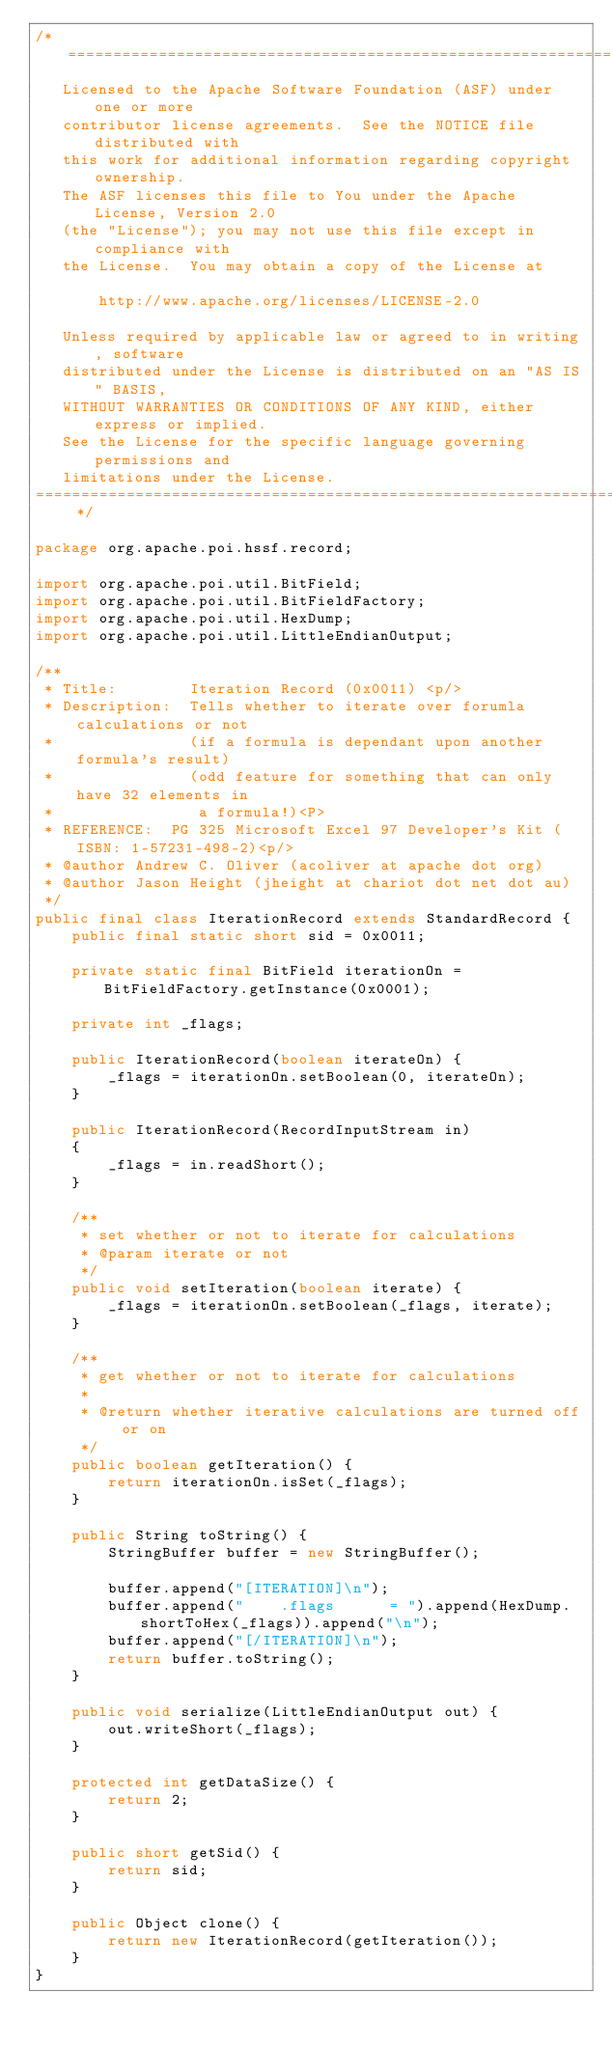Convert code to text. <code><loc_0><loc_0><loc_500><loc_500><_Java_>/* ====================================================================
   Licensed to the Apache Software Foundation (ASF) under one or more
   contributor license agreements.  See the NOTICE file distributed with
   this work for additional information regarding copyright ownership.
   The ASF licenses this file to You under the Apache License, Version 2.0
   (the "License"); you may not use this file except in compliance with
   the License.  You may obtain a copy of the License at

       http://www.apache.org/licenses/LICENSE-2.0

   Unless required by applicable law or agreed to in writing, software
   distributed under the License is distributed on an "AS IS" BASIS,
   WITHOUT WARRANTIES OR CONDITIONS OF ANY KIND, either express or implied.
   See the License for the specific language governing permissions and
   limitations under the License.
==================================================================== */

package org.apache.poi.hssf.record;

import org.apache.poi.util.BitField;
import org.apache.poi.util.BitFieldFactory;
import org.apache.poi.util.HexDump;
import org.apache.poi.util.LittleEndianOutput;

/**
 * Title:        Iteration Record (0x0011) <p/>
 * Description:  Tells whether to iterate over forumla calculations or not
 *               (if a formula is dependant upon another formula's result)
 *               (odd feature for something that can only have 32 elements in
 *                a formula!)<P>
 * REFERENCE:  PG 325 Microsoft Excel 97 Developer's Kit (ISBN: 1-57231-498-2)<p/>
 * @author Andrew C. Oliver (acoliver at apache dot org)
 * @author Jason Height (jheight at chariot dot net dot au)
 */
public final class IterationRecord extends StandardRecord {
    public final static short sid = 0x0011;

    private static final BitField iterationOn = BitFieldFactory.getInstance(0x0001);

    private int _flags;

    public IterationRecord(boolean iterateOn) {
        _flags = iterationOn.setBoolean(0, iterateOn);
    }

    public IterationRecord(RecordInputStream in)
    {
        _flags = in.readShort();
    }

    /**
     * set whether or not to iterate for calculations
     * @param iterate or not
     */
    public void setIteration(boolean iterate) {
        _flags = iterationOn.setBoolean(_flags, iterate);
    }

    /**
     * get whether or not to iterate for calculations
     *
     * @return whether iterative calculations are turned off or on
     */
    public boolean getIteration() {
        return iterationOn.isSet(_flags);
    }

    public String toString() {
        StringBuffer buffer = new StringBuffer();

        buffer.append("[ITERATION]\n");
        buffer.append("    .flags      = ").append(HexDump.shortToHex(_flags)).append("\n");
        buffer.append("[/ITERATION]\n");
        return buffer.toString();
    }

    public void serialize(LittleEndianOutput out) {
        out.writeShort(_flags);
    }

    protected int getDataSize() {
        return 2;
    }

    public short getSid() {
        return sid;
    }

    public Object clone() {
        return new IterationRecord(getIteration());
    }
}
</code> 